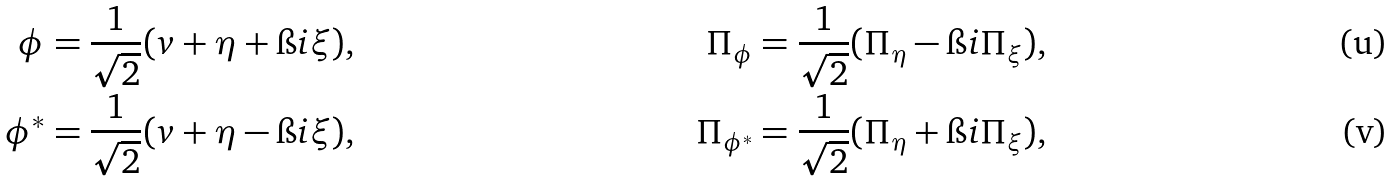<formula> <loc_0><loc_0><loc_500><loc_500>\phi & = \frac { 1 } { \sqrt { 2 } } ( v + \eta + \i i \xi ) , & \Pi _ { \phi } & = \frac { 1 } { \sqrt { 2 } } ( \Pi _ { \eta } - \i i \Pi _ { \xi } ) , \\ \phi ^ { * } & = \frac { 1 } { \sqrt { 2 } } ( v + \eta - \i i \xi ) , & \Pi _ { \phi ^ { * } } & = \frac { 1 } { \sqrt { 2 } } ( \Pi _ { \eta } + \i i \Pi _ { \xi } ) ,</formula> 